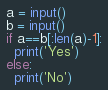<code> <loc_0><loc_0><loc_500><loc_500><_Python_>a = input()
b = input()
if a==b[:len(a)-1]:
  print('Yes')
else:
  print('No')</code> 